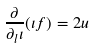<formula> <loc_0><loc_0><loc_500><loc_500>\frac { \partial } { \partial _ { l } \iota } ( \iota f ) = 2 u</formula> 